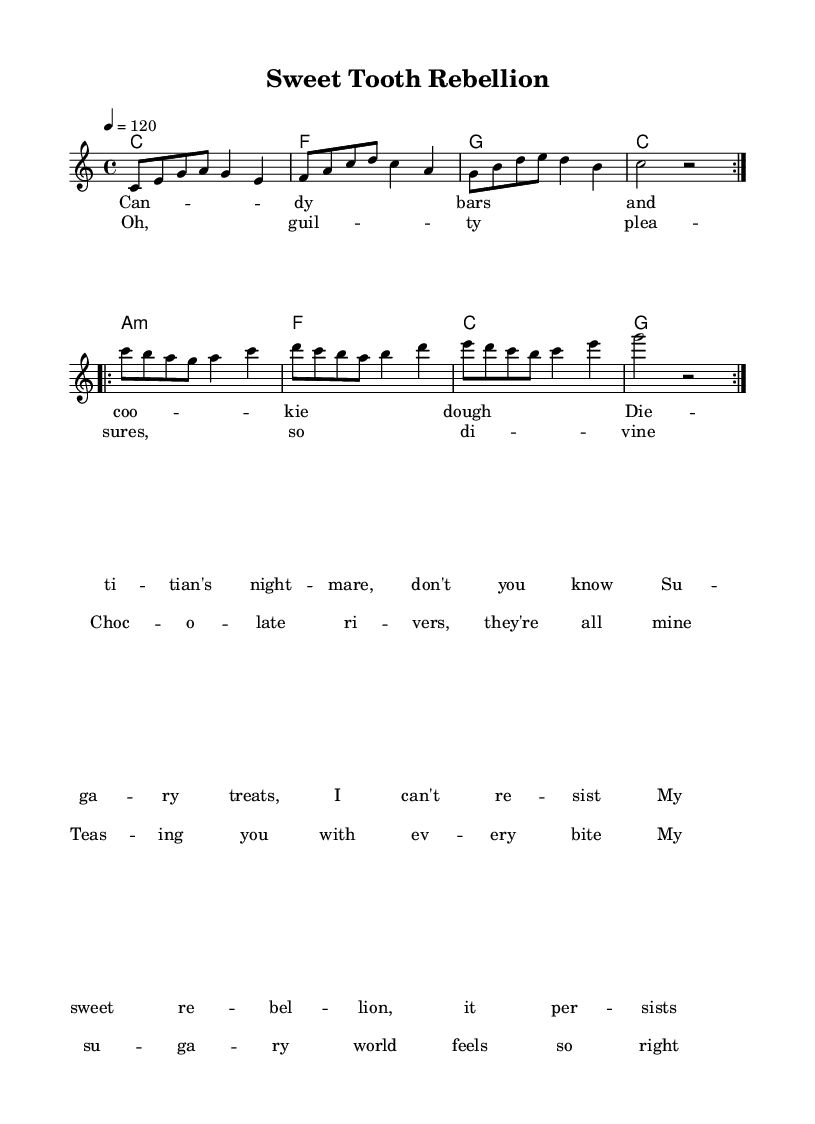What is the key signature of this music? The key signature is C major, which has no sharps or flats.
Answer: C major What is the time signature of this music? The time signature is given as 4/4, indicating four beats per measure.
Answer: 4/4 What is the tempo marking for this piece? The tempo marking is indicated as 4 equals 120, meaning there are 120 quarter note beats per minute.
Answer: 120 How many measures are repeated in the melody? The melody has two sections that are each repeated, totaling four measures due to the repeat volta notation.
Answer: 4 In what musical section does the phrase "chocolate rivers" appear? The phrase "chocolate rivers" is found in the chorus section, which is specified under the lyrics portion of the score.
Answer: Chorus What type of chord are the last two measures based on? The last two measures of the harmonies use the C major chord, as confirmed by the chord notation shown at the end of the first repetition.
Answer: C major Identify the length of the last note in the melody. The last note of the melody is a half-note, which is indicated by the “g2” notation, showing its rhythmic value.
Answer: Half-note 